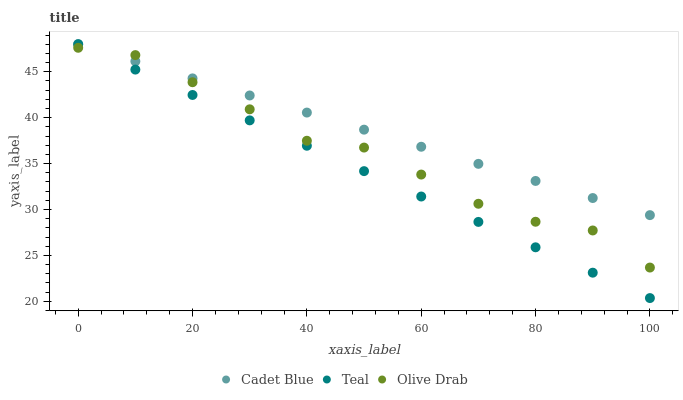Does Teal have the minimum area under the curve?
Answer yes or no. Yes. Does Cadet Blue have the maximum area under the curve?
Answer yes or no. Yes. Does Olive Drab have the minimum area under the curve?
Answer yes or no. No. Does Olive Drab have the maximum area under the curve?
Answer yes or no. No. Is Teal the smoothest?
Answer yes or no. Yes. Is Olive Drab the roughest?
Answer yes or no. Yes. Is Olive Drab the smoothest?
Answer yes or no. No. Is Teal the roughest?
Answer yes or no. No. Does Teal have the lowest value?
Answer yes or no. Yes. Does Olive Drab have the lowest value?
Answer yes or no. No. Does Teal have the highest value?
Answer yes or no. Yes. Does Olive Drab have the highest value?
Answer yes or no. No. Does Cadet Blue intersect Teal?
Answer yes or no. Yes. Is Cadet Blue less than Teal?
Answer yes or no. No. Is Cadet Blue greater than Teal?
Answer yes or no. No. 